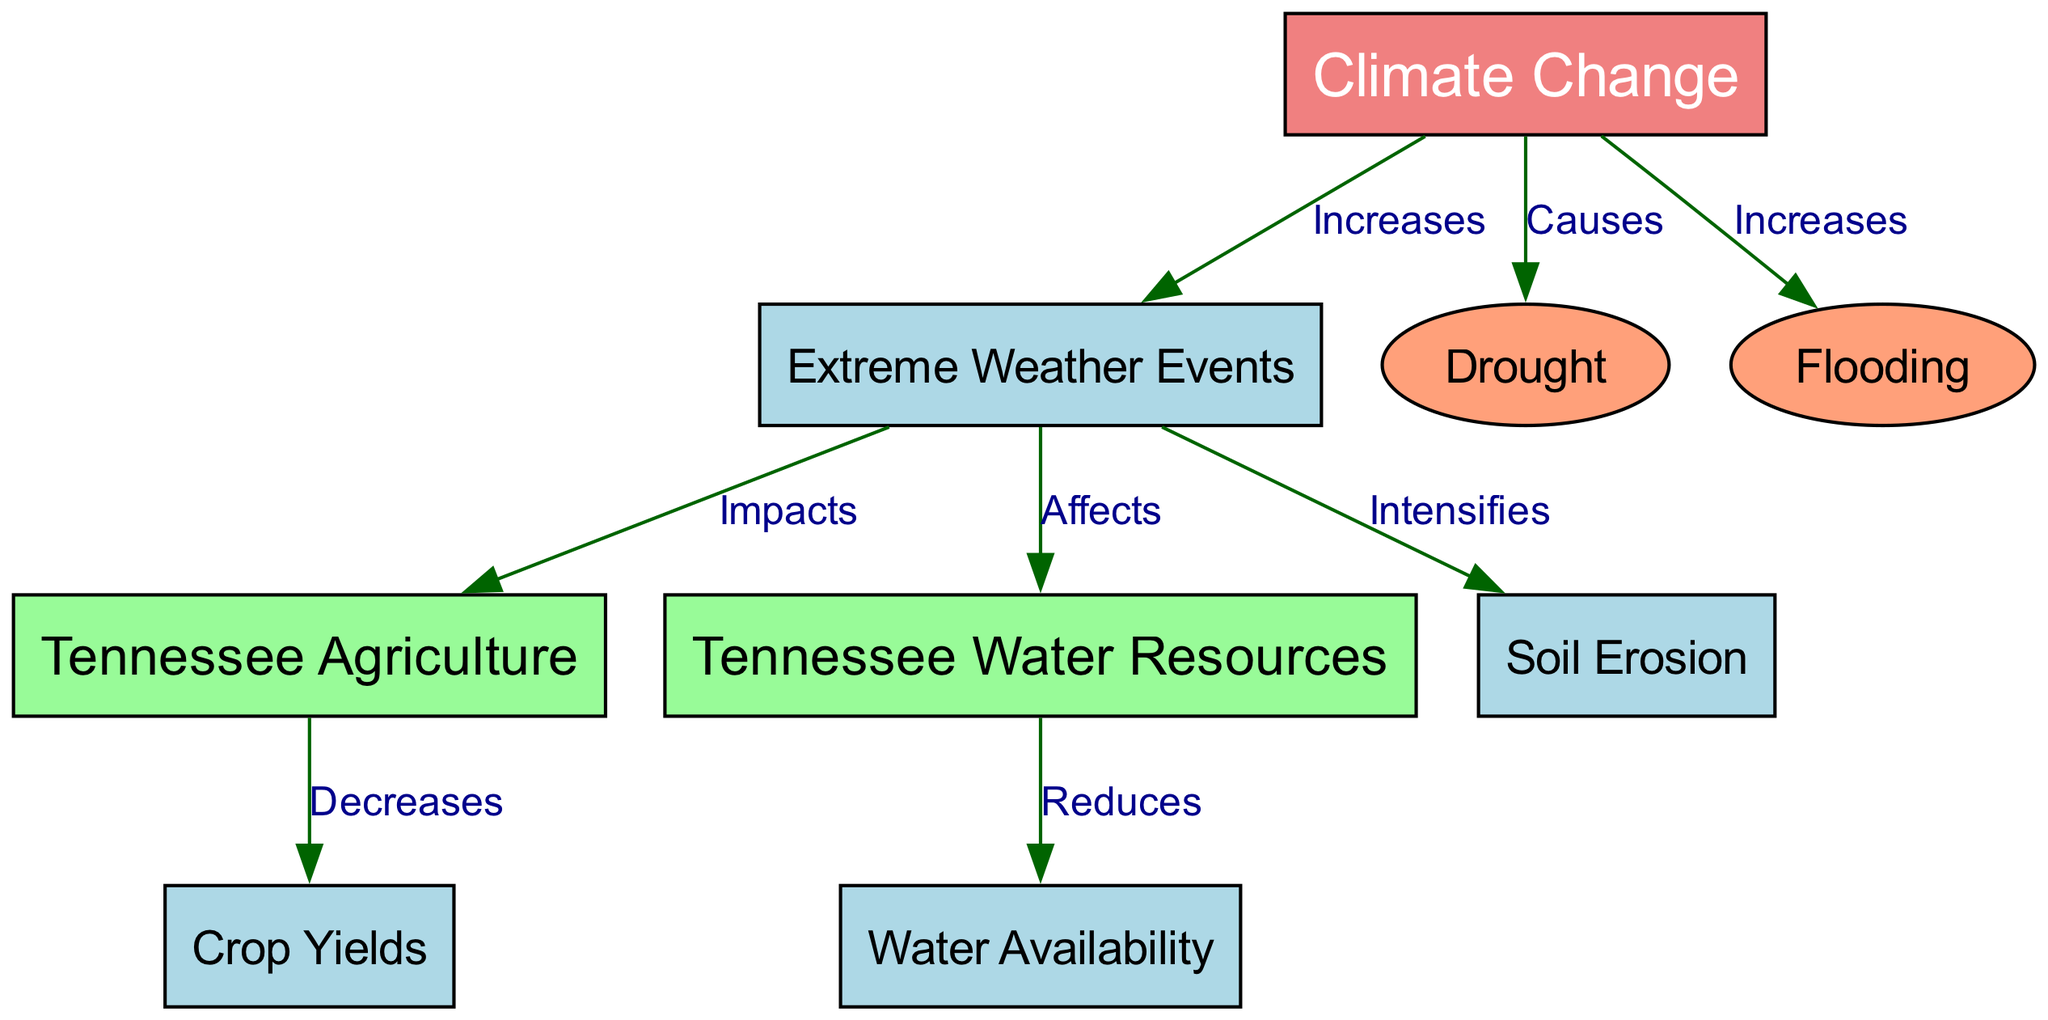What is the main influencing factor for extreme weather events? The diagram identifies climate change as the node that "increases" the occurrence of extreme weather events. This indicates that climate change is the primary factor affecting extreme weather in the context of this concept map.
Answer: Climate Change How many nodes represent specific impacts on agriculture? The nodes related to agriculture in the diagram include Tennessee Agriculture and Crop Yields. These two nodes specifically illustrate impacts or components of agriculture.
Answer: 2 What effect does extreme weather have on Tennessee agriculture? The diagram shows a directed edge from the node "Extreme Weather Events" to the node "Tennessee Agriculture," labeled "Impacts." This indicates that extreme weather negatively affects agriculture.
Answer: Impacts What increases the likelihood of flooding in Tennessee? The diagram indicates that climate change is a factor that "increases" flooding, linking it directly to the flooding node. Therefore, it can be concluded that climate change increases flooding.
Answer: Climate Change Which of the following increases due to climate change: drought or water availability? The edge leading from climate change to drought is labeled "Causes," while there is no direct relationship indicating improvement in water availability from climate change; rather, another edge indicates water availability is "reduced." Hence, drought increases from climate change while water availability decreases.
Answer: Drought How does extreme weather impact water resources? The diagram connects the node "Extreme Weather Events" to "Tennessee Water Resources" with the label "Affects." This indicates that various extreme weather events directly influence water resources in Tennessee.
Answer: Affects What effect does extreme weather have on soil erosion? The diagram indicates that extreme weather "intensifies" soil erosion, as shown by the edge connecting these two nodes. This means extreme weather events make soil erosion worse.
Answer: Intensifies What is the relationship between water resources and water availability? From the diagram, there is a directed edge from the node "Tennessee Water Resources" to "Water Availability," labeled "Reduces.” This indicates that as water resources are impacted, water availability decreases.
Answer: Reduces What are the two specific extreme weather events identified in the diagram? The diagram includes two nodes labeled "Drought" and "Flooding," which are both identified as specific extreme weather events that are influenced by climate change.
Answer: Drought and Flooding 